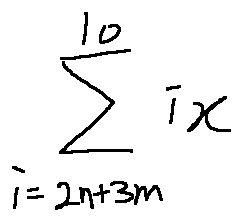Convert formula to latex. <formula><loc_0><loc_0><loc_500><loc_500>\sum \lim i t s _ { i = 2 n + 3 m } ^ { 1 0 } i x</formula> 